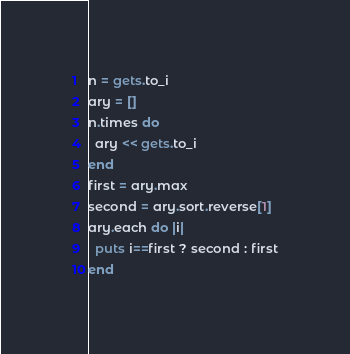<code> <loc_0><loc_0><loc_500><loc_500><_Ruby_>n = gets.to_i
ary = []
n.times do 
  ary << gets.to_i
end
first = ary.max
second = ary.sort.reverse[1]
ary.each do |i|
  puts i==first ? second : first
end
</code> 